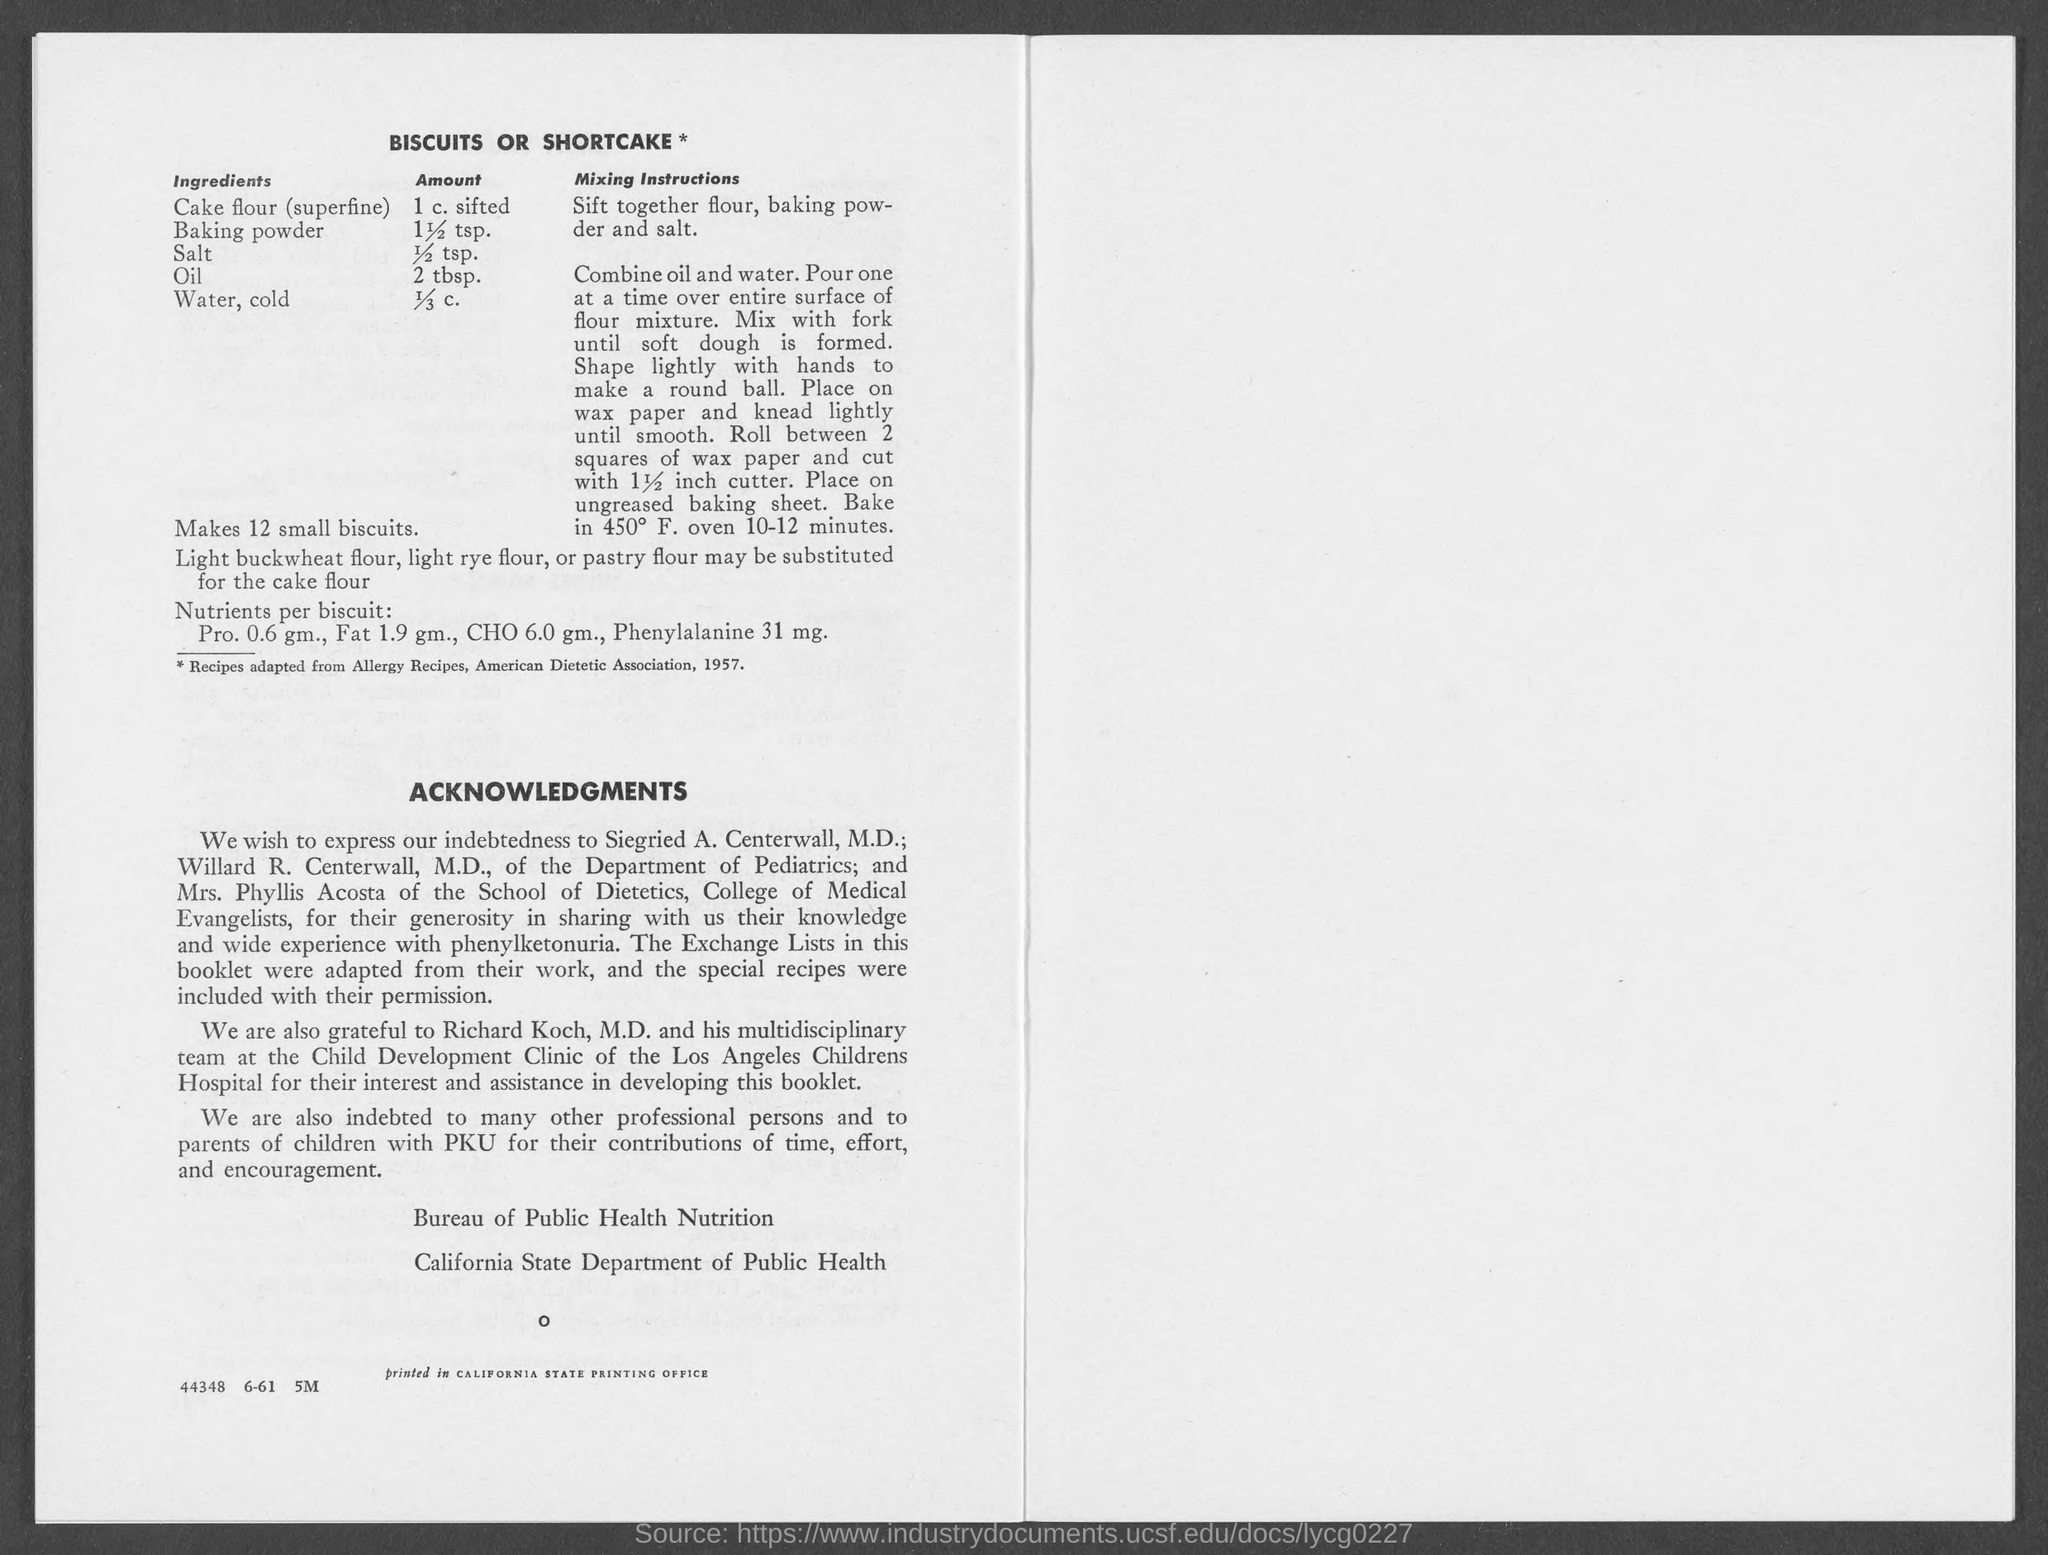Specify some key components in this picture. The amount of salt is 1/2 teaspoon. 